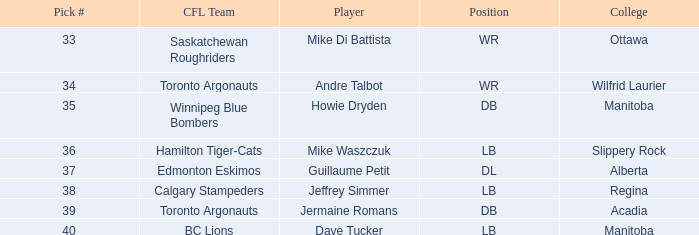What Player has a College that is alberta? Guillaume Petit. 